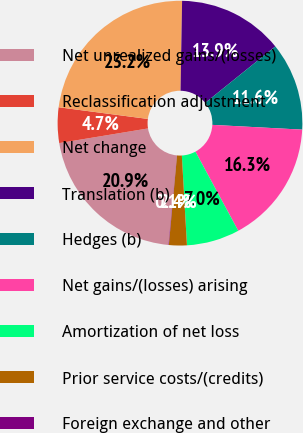Convert chart. <chart><loc_0><loc_0><loc_500><loc_500><pie_chart><fcel>Net unrealized gains/(losses)<fcel>Reclassification adjustment<fcel>Net change<fcel>Translation (b)<fcel>Hedges (b)<fcel>Net gains/(losses) arising<fcel>Amortization of net loss<fcel>Prior service costs/(credits)<fcel>Foreign exchange and other<nl><fcel>20.89%<fcel>4.68%<fcel>23.2%<fcel>13.94%<fcel>11.63%<fcel>16.26%<fcel>6.99%<fcel>2.36%<fcel>0.05%<nl></chart> 